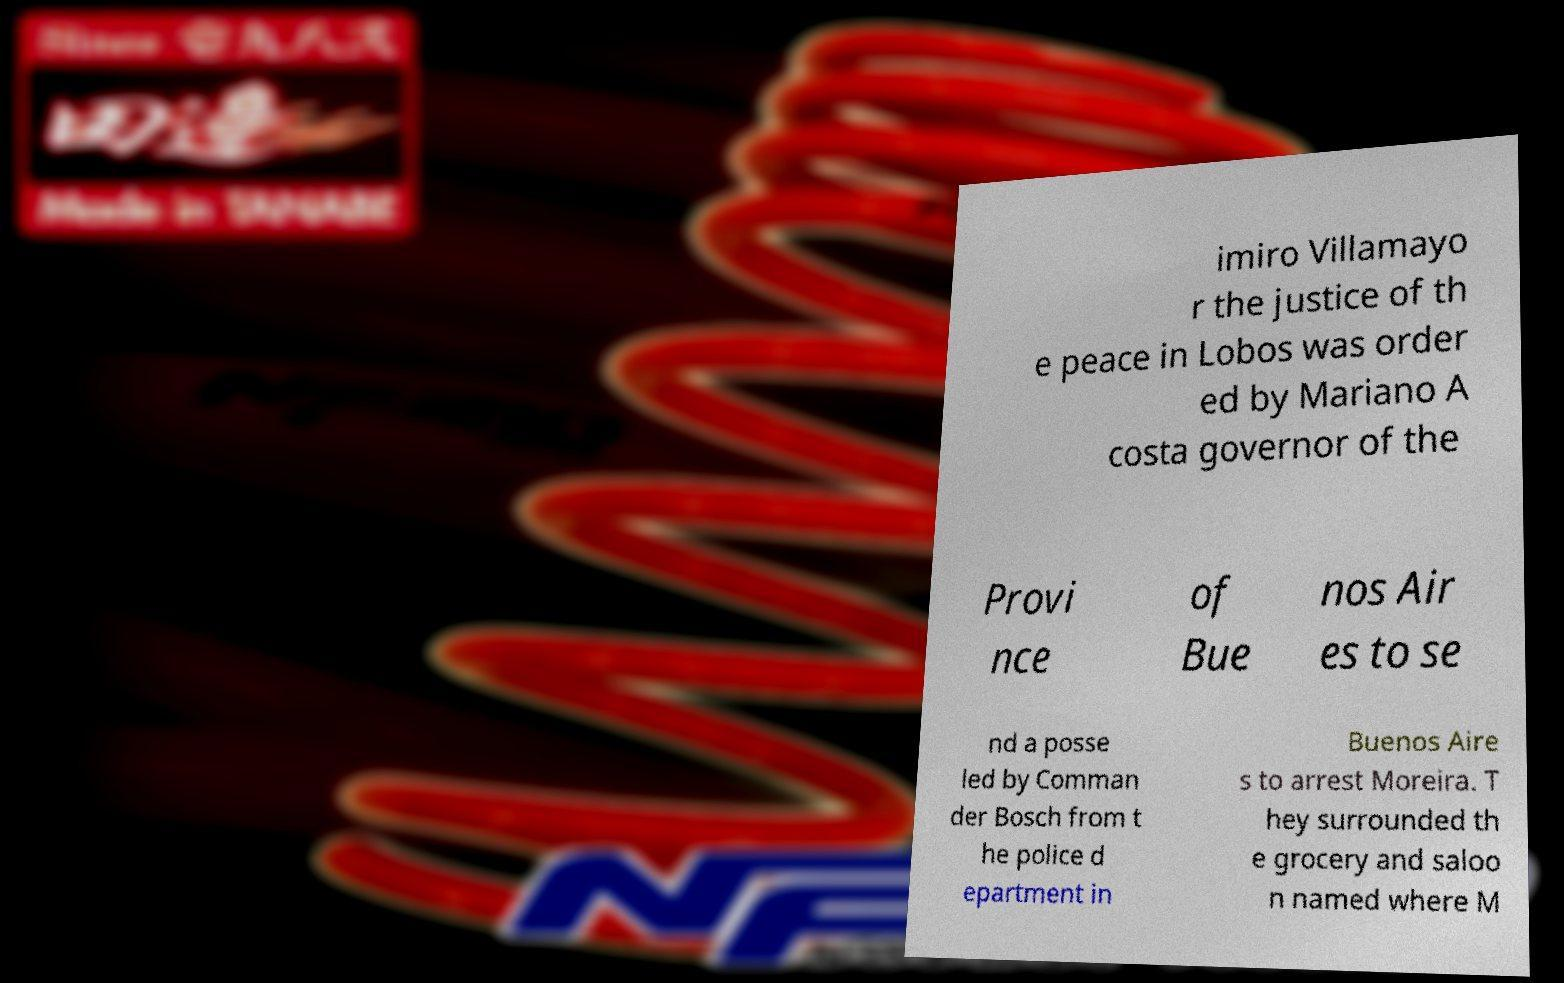Can you read and provide the text displayed in the image?This photo seems to have some interesting text. Can you extract and type it out for me? imiro Villamayo r the justice of th e peace in Lobos was order ed by Mariano A costa governor of the Provi nce of Bue nos Air es to se nd a posse led by Comman der Bosch from t he police d epartment in Buenos Aire s to arrest Moreira. T hey surrounded th e grocery and saloo n named where M 